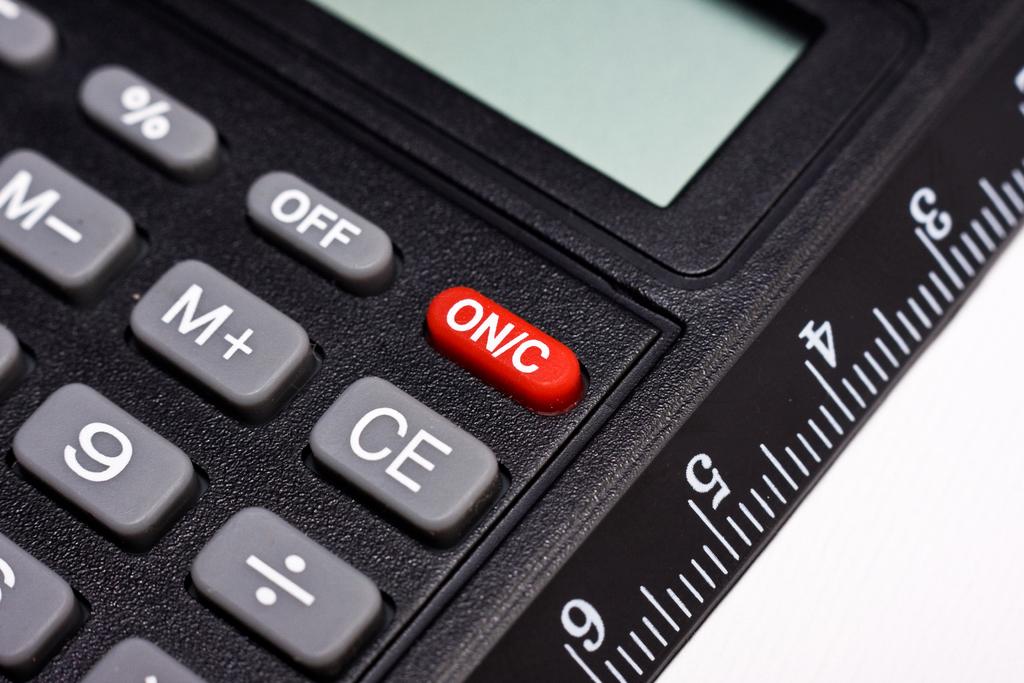What is read on the red button?
Provide a succinct answer. On/c. 